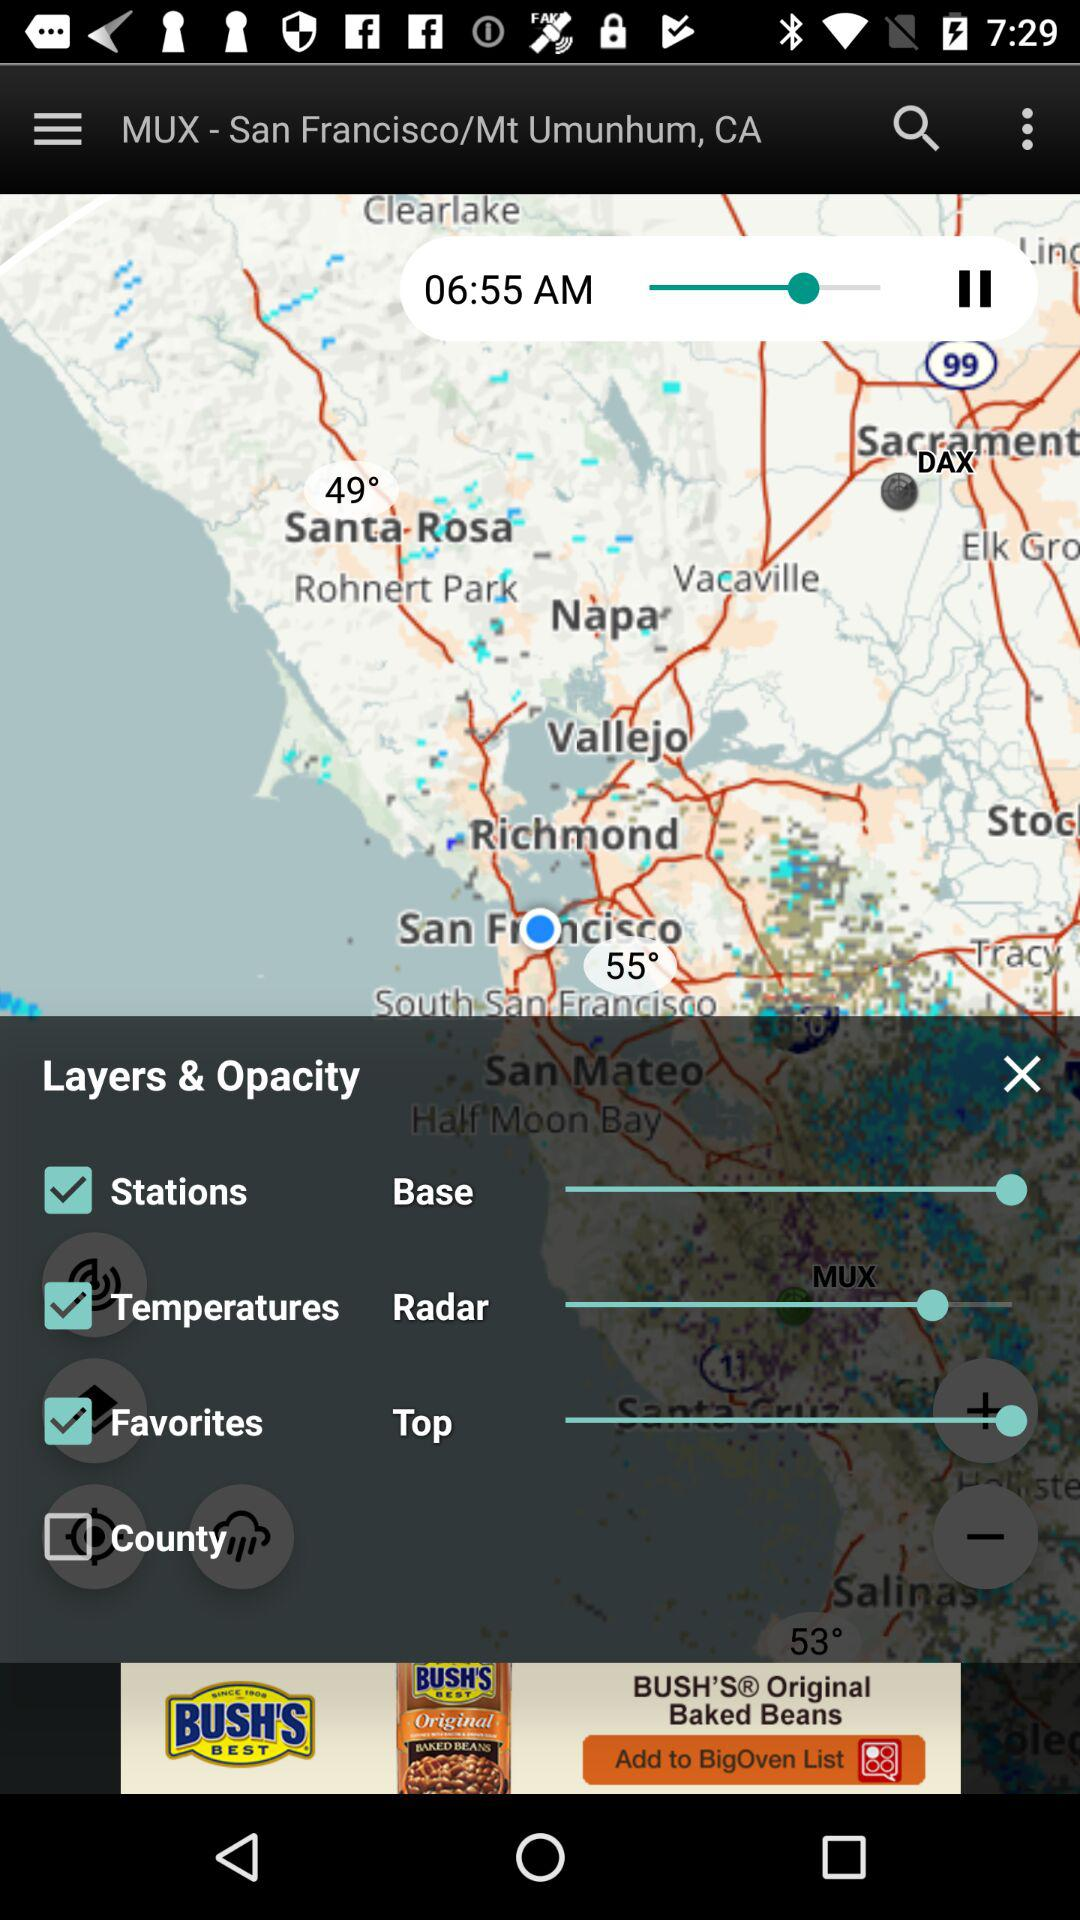What is the location of the map? The location of the map is MUX-San Francisco/Mt. Umunhum, CA. 